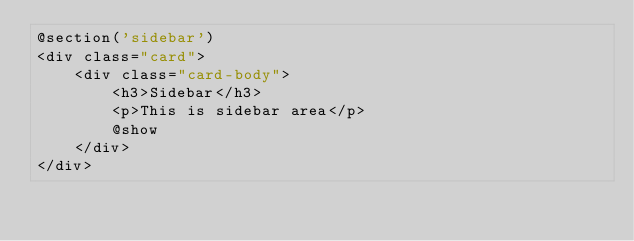Convert code to text. <code><loc_0><loc_0><loc_500><loc_500><_PHP_>@section('sidebar')
<div class="card">
    <div class="card-body">
        <h3>Sidebar</h3>
        <p>This is sidebar area</p>
        @show
    </div>
</div>
</code> 